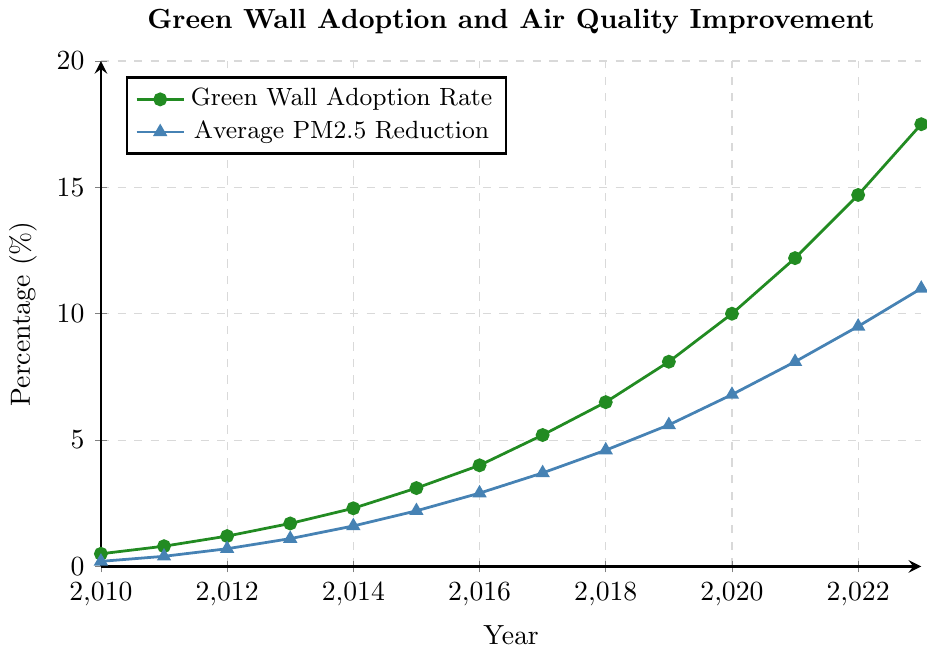What are the trends in green wall adoption rates and average PM2.5 reduction from 2010 to 2023? To determine the trends, observe the upward-sloping lines in the chart for both the green wall adoption rate (represented by circles) and the average PM2.5 reduction (represented by triangles). Both show a continuous increase from 2010 to 2023.
Answer: Continuous increase Which year had the steepest increase in green wall adoption rate? To find this, look at the steepness of the green line between each pair of consecutive years. The largest jump is from 2021 to 2022, from 12.2% to 14.7%.
Answer: 2021 to 2022 How does the average PM2.5 reduction in 2020 compare to 2015? Check the values for 2020 and 2015 in the blue line. The value for 2015 is 2.2%, and for 2020, it is 6.8%.
Answer: 2020 is higher than 2015 What's the total increase in green wall adoption rate from 2010 to 2023? Subtract the adoption rate in 2010 (0.5%) from that in 2023 (17.5%). 17.5% - 0.5% = 17%.
Answer: 17% Is there a proportional relationship between green wall adoption rates and PM2.5 reduction? Observe the similar upward patterns in both lines from 2010 to 2023. As green wall adoption increases, PM2.5 reduction also increases.
Answer: Yes In which year did the average PM2.5 reduction exceed 5% for the first time? Check when the blue line first crosses the 5% mark. This occurs between 2018 and 2019. The value in 2019 is 5.6%.
Answer: 2019 Which color corresponds to the green wall adoption rate in the chart? Observe the legend in the chart. The green wall adoption rate is marked with circles and is in green.
Answer: Green What was the average PM2.5 reduction rate over the years 2018, 2019, and 2020? Sum the PM2.5 reduction rates for these years (4.6% + 5.6% + 6.8%) and divide by 3: (4.6 + 5.6 + 6.8)/3 = 5.67%.
Answer: 5.67% Between which consecutive years did the average PM2.5 reduction rate increase the least? Identify the smallest increase by comparing the differences between consecutive years in the blue line. The smallest increase is from 2020 (6.8%) to 2021 (8.1%), which is 1.3%.
Answer: 2020 to 2021 Assess the effectiveness of green walls in improving air quality based on the given data. The data shows a consistent trend where increasing green wall adoption correlates with greater reductions in PM2.5 concentrations, indicating their effectiveness in improving air quality.
Answer: Effective 